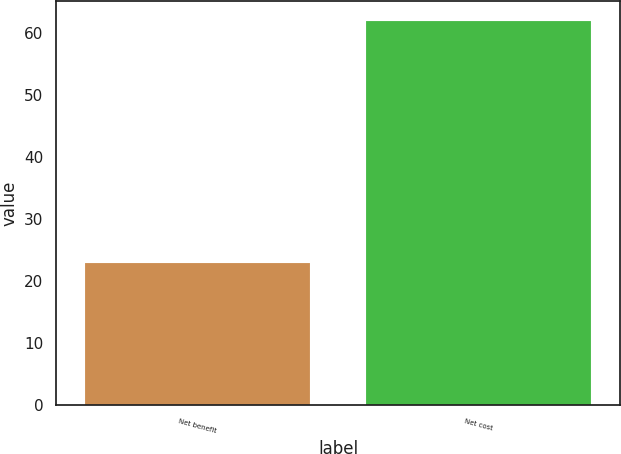Convert chart. <chart><loc_0><loc_0><loc_500><loc_500><bar_chart><fcel>Net benefit<fcel>Net cost<nl><fcel>23<fcel>62<nl></chart> 